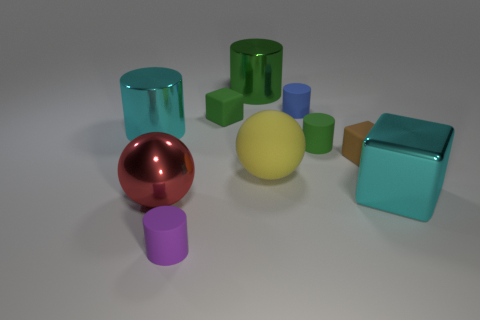The large cyan metallic thing right of the purple matte cylinder has what shape?
Provide a succinct answer. Cube. Is the material of the tiny purple cylinder the same as the large cyan cylinder?
Your answer should be very brief. No. Is there any other thing that is the same material as the tiny purple cylinder?
Give a very brief answer. Yes. There is a big yellow object that is the same shape as the large red thing; what material is it?
Your answer should be very brief. Rubber. Are there fewer tiny rubber cylinders that are to the right of the blue matte thing than red metal balls?
Give a very brief answer. No. There is a purple object; what number of tiny blue cylinders are to the left of it?
Offer a terse response. 0. There is a cyan shiny thing that is right of the big yellow matte thing; does it have the same shape as the cyan shiny thing to the left of the green rubber cube?
Your response must be concise. No. What is the shape of the object that is in front of the yellow rubber thing and to the right of the yellow ball?
Give a very brief answer. Cube. The yellow thing that is made of the same material as the tiny green cylinder is what size?
Give a very brief answer. Large. Are there fewer blue matte things than gray rubber objects?
Provide a succinct answer. No. 